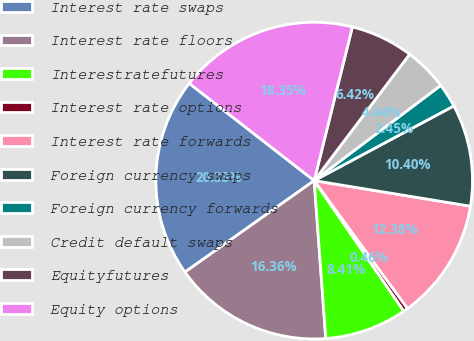Convert chart to OTSL. <chart><loc_0><loc_0><loc_500><loc_500><pie_chart><fcel>Interest rate swaps<fcel>Interest rate floors<fcel>Interestratefutures<fcel>Interest rate options<fcel>Interest rate forwards<fcel>Foreign currency swaps<fcel>Foreign currency forwards<fcel>Credit default swaps<fcel>Equityfutures<fcel>Equity options<nl><fcel>20.33%<fcel>16.36%<fcel>8.41%<fcel>0.46%<fcel>12.38%<fcel>10.4%<fcel>2.45%<fcel>4.44%<fcel>6.42%<fcel>18.35%<nl></chart> 